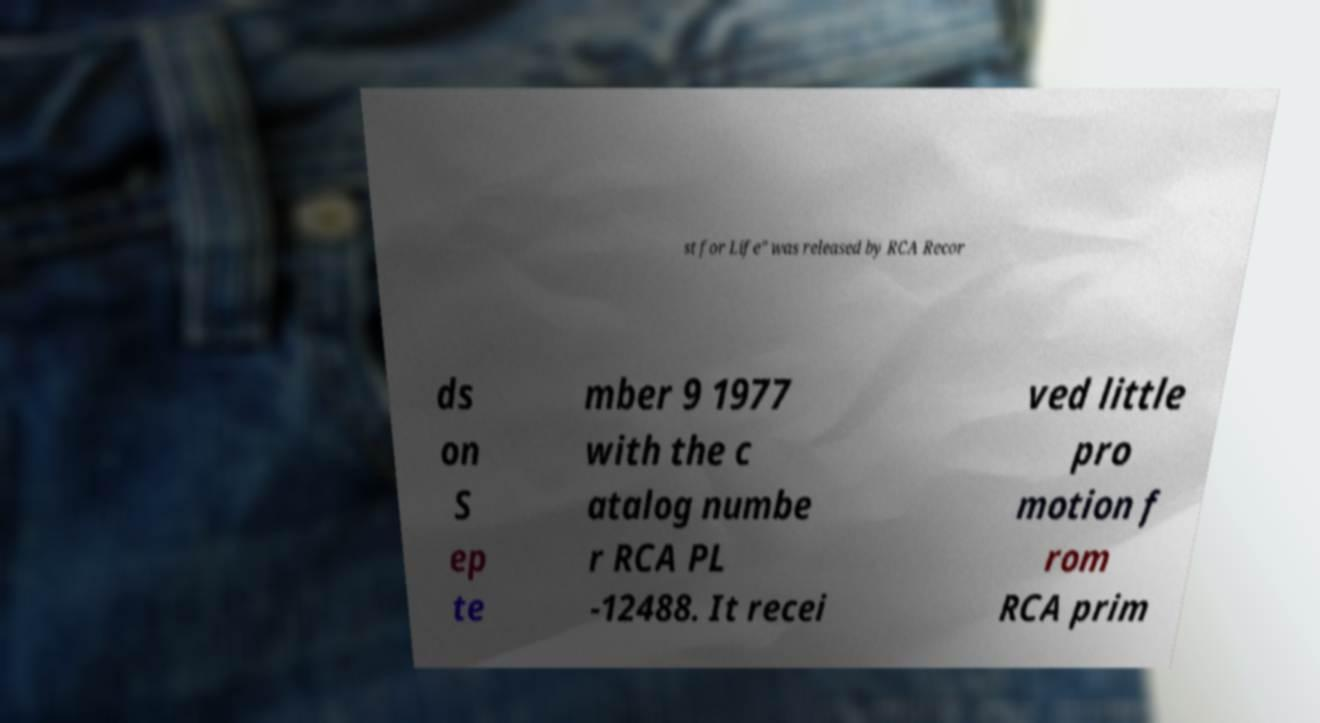What messages or text are displayed in this image? I need them in a readable, typed format. st for Life" was released by RCA Recor ds on S ep te mber 9 1977 with the c atalog numbe r RCA PL -12488. It recei ved little pro motion f rom RCA prim 